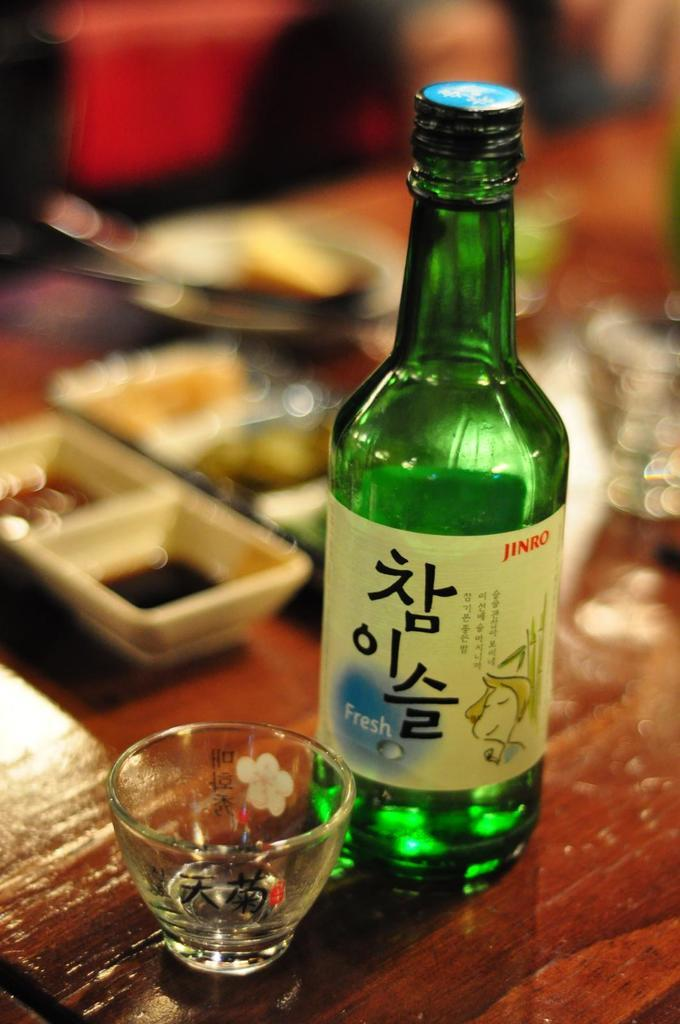<image>
Describe the image concisely. Jinro Beer bottle with a cup that is being served at a restaurant. 